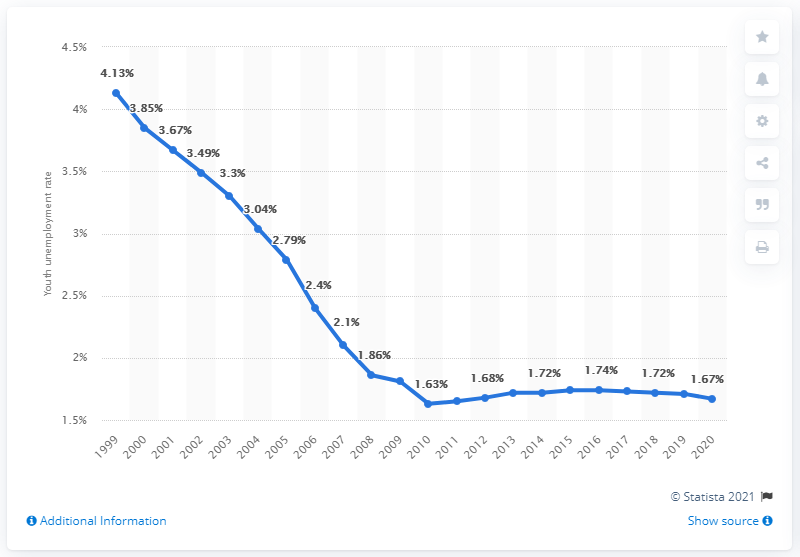Mention a couple of crucial points in this snapshot. In 2020, the youth unemployment rate in Laos was 1.67%. 